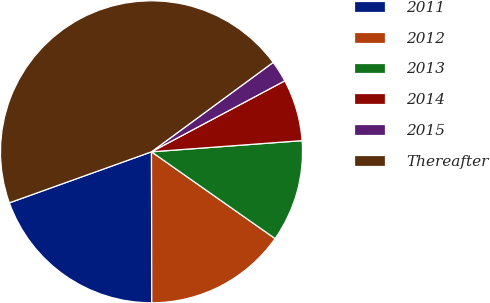<chart> <loc_0><loc_0><loc_500><loc_500><pie_chart><fcel>2011<fcel>2012<fcel>2013<fcel>2014<fcel>2015<fcel>Thereafter<nl><fcel>19.54%<fcel>15.23%<fcel>10.92%<fcel>6.61%<fcel>2.3%<fcel>45.4%<nl></chart> 